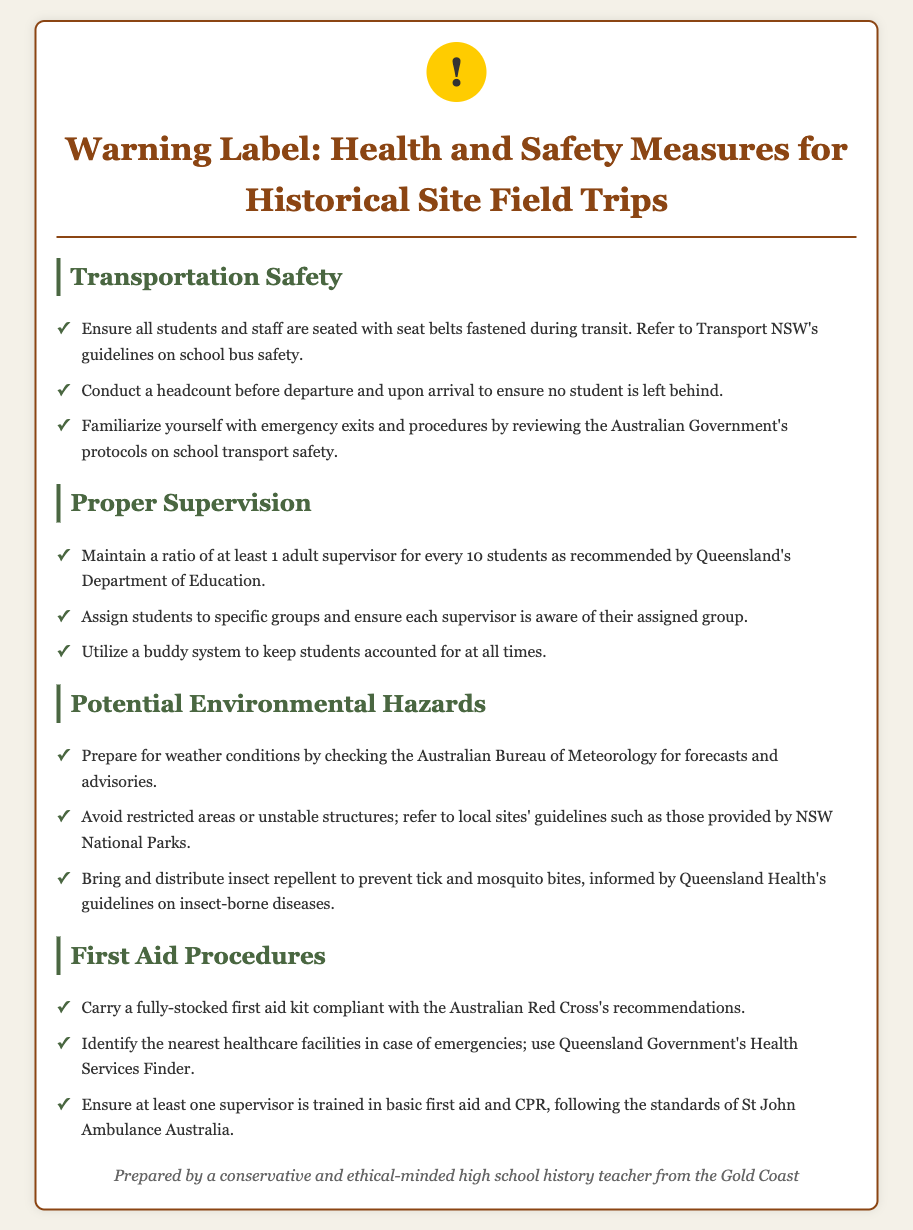What is the recommended adult-to-student ratio for supervision? The document specifies maintaining a ratio of at least 1 adult supervisor for every 10 students, as recommended by Queensland's Department of Education.
Answer: 1:10 What should be carried in the first aid kit? The document states to carry a fully-stocked first aid kit compliant with the Australian Red Cross's recommendations.
Answer: Fully-stocked first aid kit What is the purpose of the buddy system? The document mentions utilizing a buddy system to keep students accounted for at all times, indicating its role in supervision.
Answer: Keep students accounted for Which organization's guidelines should be referred to for school bus safety? The document mentions referring to Transport NSW's guidelines on school bus safety for transportation measures.
Answer: Transport NSW What should be checked to prepare for weather conditions? The document advises checking the Australian Bureau of Meteorology for forecasts and advisories related to weather conditions.
Answer: Australian Bureau of Meteorology What type of training should at least one supervisor have? The document highlights that at least one supervisor should be trained in basic first aid and CPR, emphasizing the importance of first aid knowledge.
Answer: Basic first aid and CPR 